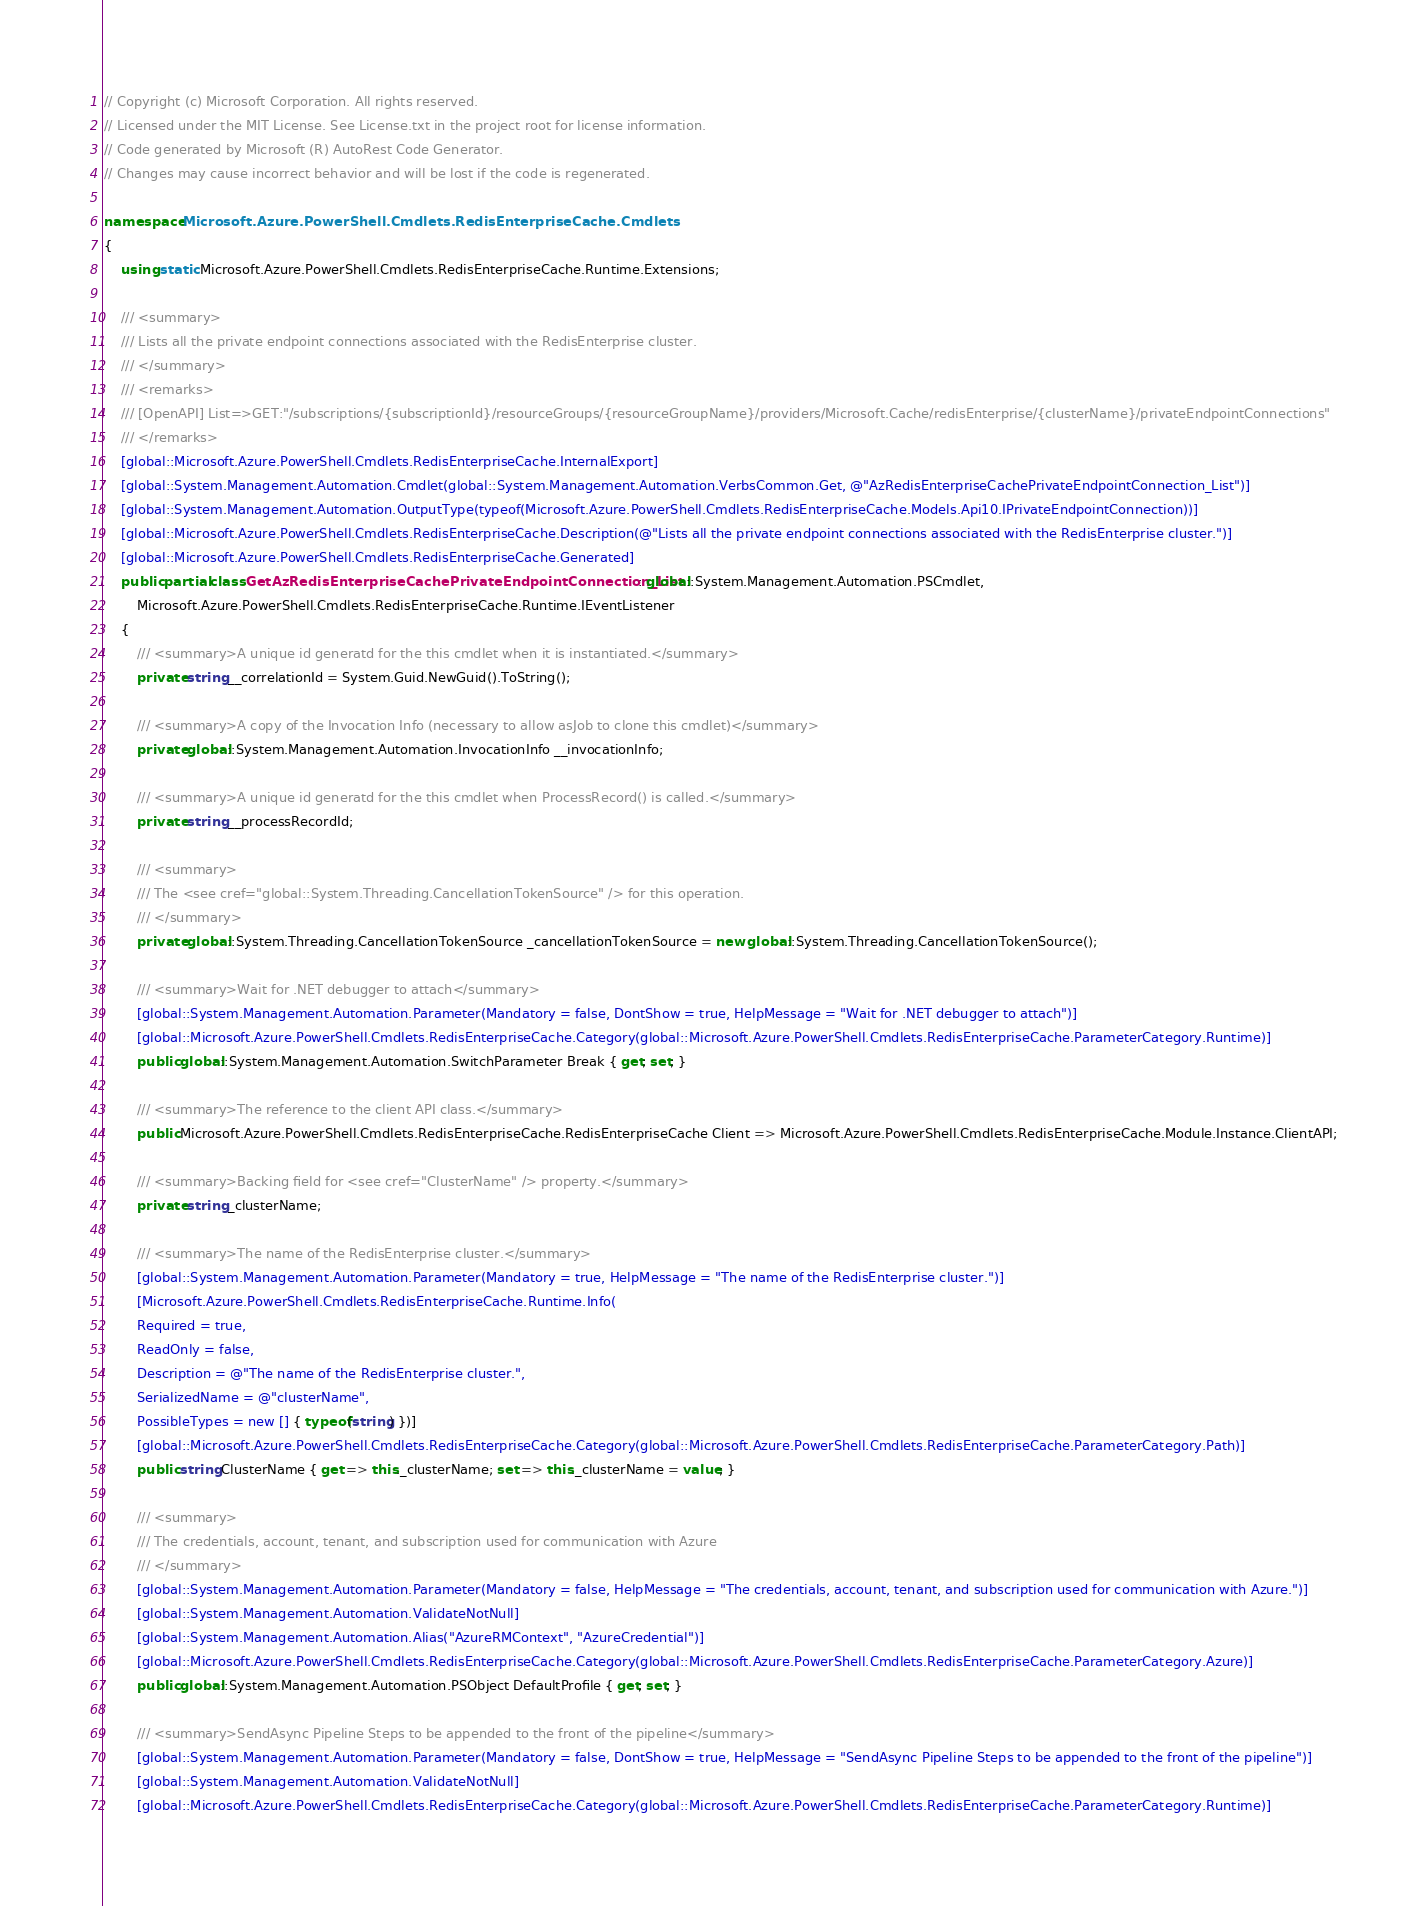Convert code to text. <code><loc_0><loc_0><loc_500><loc_500><_C#_>// Copyright (c) Microsoft Corporation. All rights reserved.
// Licensed under the MIT License. See License.txt in the project root for license information.
// Code generated by Microsoft (R) AutoRest Code Generator.
// Changes may cause incorrect behavior and will be lost if the code is regenerated.

namespace Microsoft.Azure.PowerShell.Cmdlets.RedisEnterpriseCache.Cmdlets
{
    using static Microsoft.Azure.PowerShell.Cmdlets.RedisEnterpriseCache.Runtime.Extensions;

    /// <summary>
    /// Lists all the private endpoint connections associated with the RedisEnterprise cluster.
    /// </summary>
    /// <remarks>
    /// [OpenAPI] List=>GET:"/subscriptions/{subscriptionId}/resourceGroups/{resourceGroupName}/providers/Microsoft.Cache/redisEnterprise/{clusterName}/privateEndpointConnections"
    /// </remarks>
    [global::Microsoft.Azure.PowerShell.Cmdlets.RedisEnterpriseCache.InternalExport]
    [global::System.Management.Automation.Cmdlet(global::System.Management.Automation.VerbsCommon.Get, @"AzRedisEnterpriseCachePrivateEndpointConnection_List")]
    [global::System.Management.Automation.OutputType(typeof(Microsoft.Azure.PowerShell.Cmdlets.RedisEnterpriseCache.Models.Api10.IPrivateEndpointConnection))]
    [global::Microsoft.Azure.PowerShell.Cmdlets.RedisEnterpriseCache.Description(@"Lists all the private endpoint connections associated with the RedisEnterprise cluster.")]
    [global::Microsoft.Azure.PowerShell.Cmdlets.RedisEnterpriseCache.Generated]
    public partial class GetAzRedisEnterpriseCachePrivateEndpointConnection_List : global::System.Management.Automation.PSCmdlet,
        Microsoft.Azure.PowerShell.Cmdlets.RedisEnterpriseCache.Runtime.IEventListener
    {
        /// <summary>A unique id generatd for the this cmdlet when it is instantiated.</summary>
        private string __correlationId = System.Guid.NewGuid().ToString();

        /// <summary>A copy of the Invocation Info (necessary to allow asJob to clone this cmdlet)</summary>
        private global::System.Management.Automation.InvocationInfo __invocationInfo;

        /// <summary>A unique id generatd for the this cmdlet when ProcessRecord() is called.</summary>
        private string __processRecordId;

        /// <summary>
        /// The <see cref="global::System.Threading.CancellationTokenSource" /> for this operation.
        /// </summary>
        private global::System.Threading.CancellationTokenSource _cancellationTokenSource = new global::System.Threading.CancellationTokenSource();

        /// <summary>Wait for .NET debugger to attach</summary>
        [global::System.Management.Automation.Parameter(Mandatory = false, DontShow = true, HelpMessage = "Wait for .NET debugger to attach")]
        [global::Microsoft.Azure.PowerShell.Cmdlets.RedisEnterpriseCache.Category(global::Microsoft.Azure.PowerShell.Cmdlets.RedisEnterpriseCache.ParameterCategory.Runtime)]
        public global::System.Management.Automation.SwitchParameter Break { get; set; }

        /// <summary>The reference to the client API class.</summary>
        public Microsoft.Azure.PowerShell.Cmdlets.RedisEnterpriseCache.RedisEnterpriseCache Client => Microsoft.Azure.PowerShell.Cmdlets.RedisEnterpriseCache.Module.Instance.ClientAPI;

        /// <summary>Backing field for <see cref="ClusterName" /> property.</summary>
        private string _clusterName;

        /// <summary>The name of the RedisEnterprise cluster.</summary>
        [global::System.Management.Automation.Parameter(Mandatory = true, HelpMessage = "The name of the RedisEnterprise cluster.")]
        [Microsoft.Azure.PowerShell.Cmdlets.RedisEnterpriseCache.Runtime.Info(
        Required = true,
        ReadOnly = false,
        Description = @"The name of the RedisEnterprise cluster.",
        SerializedName = @"clusterName",
        PossibleTypes = new [] { typeof(string) })]
        [global::Microsoft.Azure.PowerShell.Cmdlets.RedisEnterpriseCache.Category(global::Microsoft.Azure.PowerShell.Cmdlets.RedisEnterpriseCache.ParameterCategory.Path)]
        public string ClusterName { get => this._clusterName; set => this._clusterName = value; }

        /// <summary>
        /// The credentials, account, tenant, and subscription used for communication with Azure
        /// </summary>
        [global::System.Management.Automation.Parameter(Mandatory = false, HelpMessage = "The credentials, account, tenant, and subscription used for communication with Azure.")]
        [global::System.Management.Automation.ValidateNotNull]
        [global::System.Management.Automation.Alias("AzureRMContext", "AzureCredential")]
        [global::Microsoft.Azure.PowerShell.Cmdlets.RedisEnterpriseCache.Category(global::Microsoft.Azure.PowerShell.Cmdlets.RedisEnterpriseCache.ParameterCategory.Azure)]
        public global::System.Management.Automation.PSObject DefaultProfile { get; set; }

        /// <summary>SendAsync Pipeline Steps to be appended to the front of the pipeline</summary>
        [global::System.Management.Automation.Parameter(Mandatory = false, DontShow = true, HelpMessage = "SendAsync Pipeline Steps to be appended to the front of the pipeline")]
        [global::System.Management.Automation.ValidateNotNull]
        [global::Microsoft.Azure.PowerShell.Cmdlets.RedisEnterpriseCache.Category(global::Microsoft.Azure.PowerShell.Cmdlets.RedisEnterpriseCache.ParameterCategory.Runtime)]</code> 